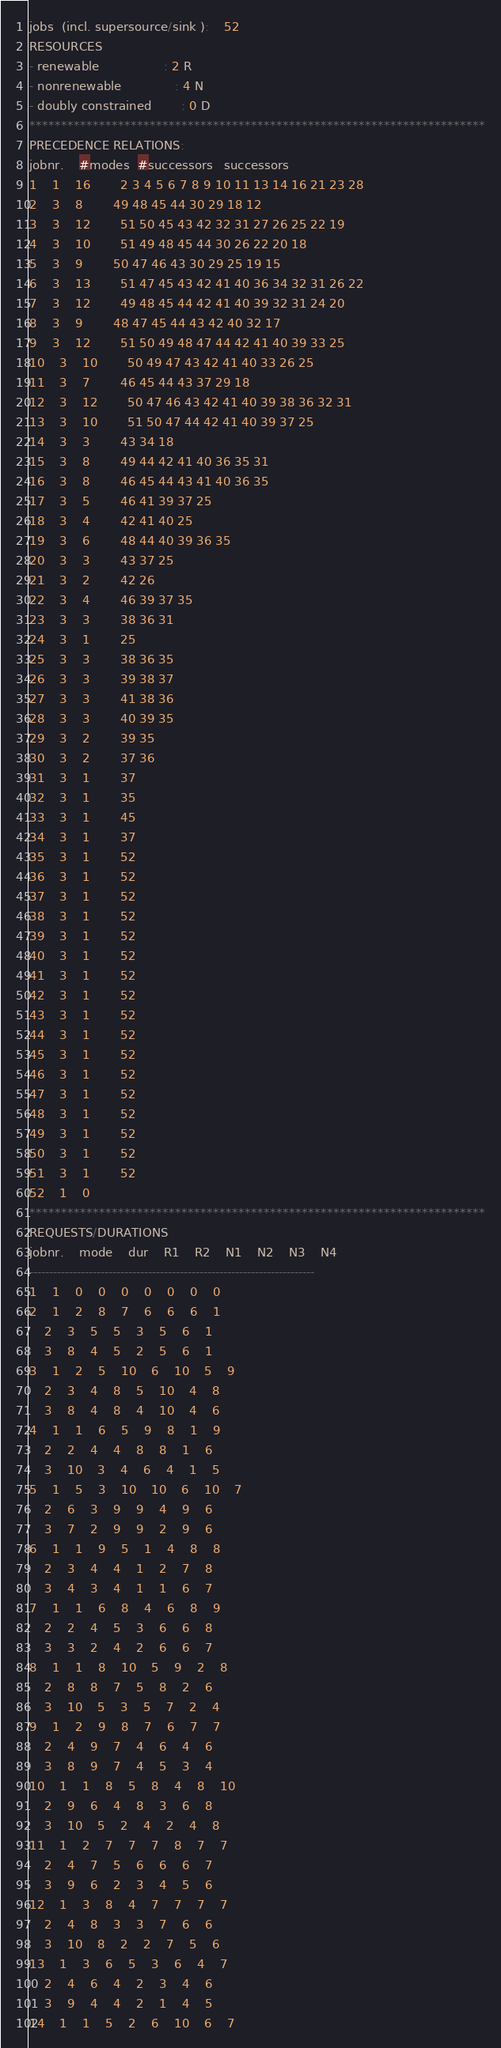<code> <loc_0><loc_0><loc_500><loc_500><_ObjectiveC_>jobs  (incl. supersource/sink ):	52
RESOURCES
- renewable                 : 2 R
- nonrenewable              : 4 N
- doubly constrained        : 0 D
************************************************************************
PRECEDENCE RELATIONS:
jobnr.    #modes  #successors   successors
1	1	16		2 3 4 5 6 7 8 9 10 11 13 14 16 21 23 28 
2	3	8		49 48 45 44 30 29 18 12 
3	3	12		51 50 45 43 42 32 31 27 26 25 22 19 
4	3	10		51 49 48 45 44 30 26 22 20 18 
5	3	9		50 47 46 43 30 29 25 19 15 
6	3	13		51 47 45 43 42 41 40 36 34 32 31 26 22 
7	3	12		49 48 45 44 42 41 40 39 32 31 24 20 
8	3	9		48 47 45 44 43 42 40 32 17 
9	3	12		51 50 49 48 47 44 42 41 40 39 33 25 
10	3	10		50 49 47 43 42 41 40 33 26 25 
11	3	7		46 45 44 43 37 29 18 
12	3	12		50 47 46 43 42 41 40 39 38 36 32 31 
13	3	10		51 50 47 44 42 41 40 39 37 25 
14	3	3		43 34 18 
15	3	8		49 44 42 41 40 36 35 31 
16	3	8		46 45 44 43 41 40 36 35 
17	3	5		46 41 39 37 25 
18	3	4		42 41 40 25 
19	3	6		48 44 40 39 36 35 
20	3	3		43 37 25 
21	3	2		42 26 
22	3	4		46 39 37 35 
23	3	3		38 36 31 
24	3	1		25 
25	3	3		38 36 35 
26	3	3		39 38 37 
27	3	3		41 38 36 
28	3	3		40 39 35 
29	3	2		39 35 
30	3	2		37 36 
31	3	1		37 
32	3	1		35 
33	3	1		45 
34	3	1		37 
35	3	1		52 
36	3	1		52 
37	3	1		52 
38	3	1		52 
39	3	1		52 
40	3	1		52 
41	3	1		52 
42	3	1		52 
43	3	1		52 
44	3	1		52 
45	3	1		52 
46	3	1		52 
47	3	1		52 
48	3	1		52 
49	3	1		52 
50	3	1		52 
51	3	1		52 
52	1	0		
************************************************************************
REQUESTS/DURATIONS
jobnr.	mode	dur	R1	R2	N1	N2	N3	N4	
------------------------------------------------------------------------
1	1	0	0	0	0	0	0	0	
2	1	2	8	7	6	6	6	1	
	2	3	5	5	3	5	6	1	
	3	8	4	5	2	5	6	1	
3	1	2	5	10	6	10	5	9	
	2	3	4	8	5	10	4	8	
	3	8	4	8	4	10	4	6	
4	1	1	6	5	9	8	1	9	
	2	2	4	4	8	8	1	6	
	3	10	3	4	6	4	1	5	
5	1	5	3	10	10	6	10	7	
	2	6	3	9	9	4	9	6	
	3	7	2	9	9	2	9	6	
6	1	1	9	5	1	4	8	8	
	2	3	4	4	1	2	7	8	
	3	4	3	4	1	1	6	7	
7	1	1	6	8	4	6	8	9	
	2	2	4	5	3	6	6	8	
	3	3	2	4	2	6	6	7	
8	1	1	8	10	5	9	2	8	
	2	8	8	7	5	8	2	6	
	3	10	5	3	5	7	2	4	
9	1	2	9	8	7	6	7	7	
	2	4	9	7	4	6	4	6	
	3	8	9	7	4	5	3	4	
10	1	1	8	5	8	4	8	10	
	2	9	6	4	8	3	6	8	
	3	10	5	2	4	2	4	8	
11	1	2	7	7	7	8	7	7	
	2	4	7	5	6	6	6	7	
	3	9	6	2	3	4	5	6	
12	1	3	8	4	7	7	7	7	
	2	4	8	3	3	7	6	6	
	3	10	8	2	2	7	5	6	
13	1	3	6	5	3	6	4	7	
	2	4	6	4	2	3	4	6	
	3	9	4	4	2	1	4	5	
14	1	1	5	2	6	10	6	7	</code> 